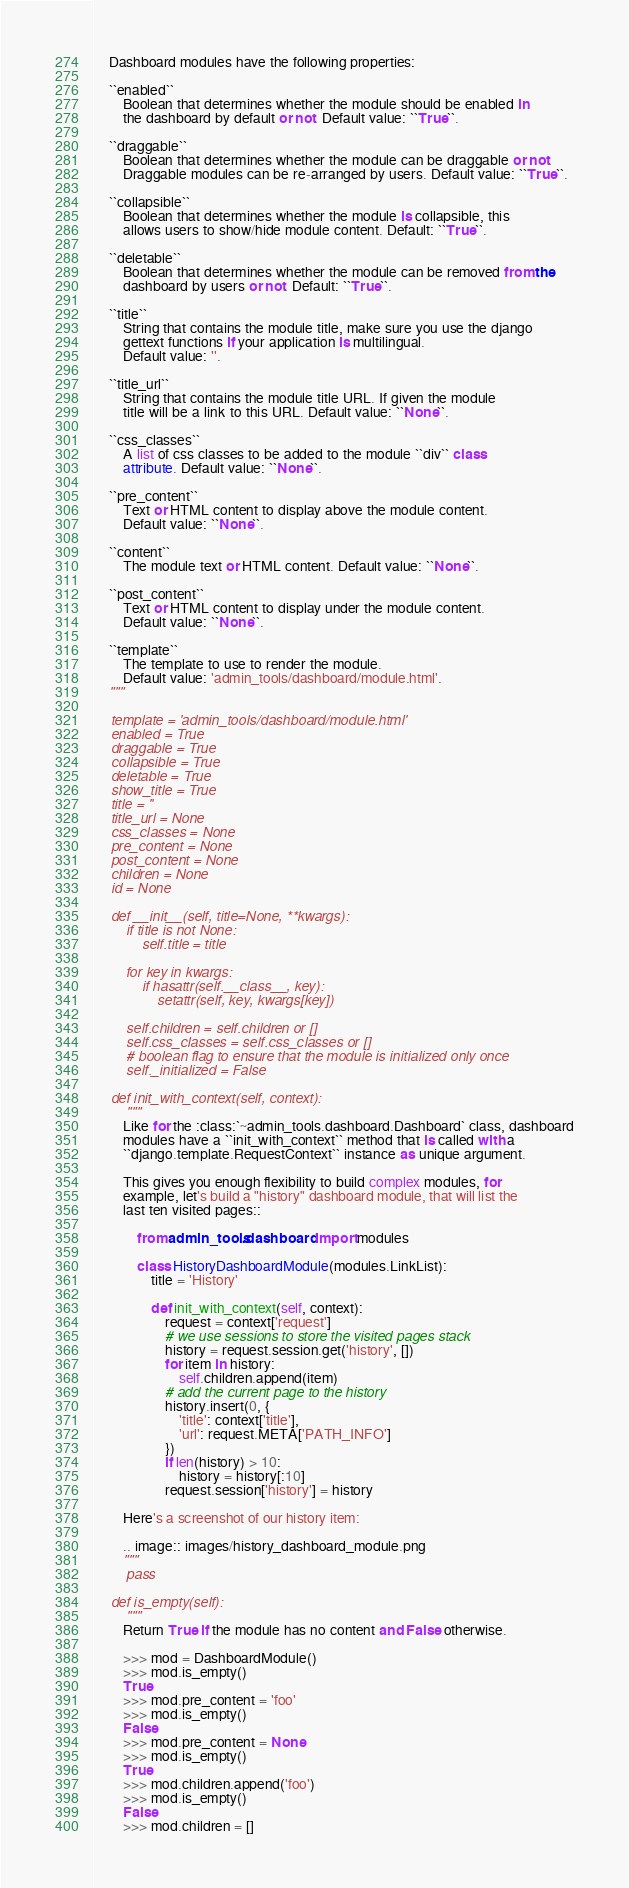Convert code to text. <code><loc_0><loc_0><loc_500><loc_500><_Python_>    Dashboard modules have the following properties:

    ``enabled``
        Boolean that determines whether the module should be enabled in
        the dashboard by default or not. Default value: ``True``.

    ``draggable``
        Boolean that determines whether the module can be draggable or not.
        Draggable modules can be re-arranged by users. Default value: ``True``.

    ``collapsible``
        Boolean that determines whether the module is collapsible, this
        allows users to show/hide module content. Default: ``True``.

    ``deletable``
        Boolean that determines whether the module can be removed from the
        dashboard by users or not. Default: ``True``.

    ``title``
        String that contains the module title, make sure you use the django
        gettext functions if your application is multilingual.
        Default value: ''.

    ``title_url``
        String that contains the module title URL. If given the module
        title will be a link to this URL. Default value: ``None``.

    ``css_classes``
        A list of css classes to be added to the module ``div`` class
        attribute. Default value: ``None``.

    ``pre_content``
        Text or HTML content to display above the module content.
        Default value: ``None``.

    ``content``
        The module text or HTML content. Default value: ``None``.

    ``post_content``
        Text or HTML content to display under the module content.
        Default value: ``None``.

    ``template``
        The template to use to render the module.
        Default value: 'admin_tools/dashboard/module.html'.
    """

    template = 'admin_tools/dashboard/module.html'
    enabled = True
    draggable = True
    collapsible = True
    deletable = True
    show_title = True
    title = ''
    title_url = None
    css_classes = None
    pre_content = None
    post_content = None
    children = None
    id = None

    def __init__(self, title=None, **kwargs):
        if title is not None:
            self.title = title

        for key in kwargs:
            if hasattr(self.__class__, key):
                setattr(self, key, kwargs[key])

        self.children = self.children or []
        self.css_classes = self.css_classes or []
        # boolean flag to ensure that the module is initialized only once
        self._initialized = False

    def init_with_context(self, context):
        """
        Like for the :class:`~admin_tools.dashboard.Dashboard` class, dashboard
        modules have a ``init_with_context`` method that is called with a
        ``django.template.RequestContext`` instance as unique argument.

        This gives you enough flexibility to build complex modules, for
        example, let's build a "history" dashboard module, that will list the
        last ten visited pages::

            from admin_tools.dashboard import modules

            class HistoryDashboardModule(modules.LinkList):
                title = 'History'

                def init_with_context(self, context):
                    request = context['request']
                    # we use sessions to store the visited pages stack
                    history = request.session.get('history', [])
                    for item in history:
                        self.children.append(item)
                    # add the current page to the history
                    history.insert(0, {
                        'title': context['title'],
                        'url': request.META['PATH_INFO']
                    })
                    if len(history) > 10:
                        history = history[:10]
                    request.session['history'] = history

        Here's a screenshot of our history item:

        .. image:: images/history_dashboard_module.png
        """
        pass

    def is_empty(self):
        """
        Return True if the module has no content and False otherwise.

        >>> mod = DashboardModule()
        >>> mod.is_empty()
        True
        >>> mod.pre_content = 'foo'
        >>> mod.is_empty()
        False
        >>> mod.pre_content = None
        >>> mod.is_empty()
        True
        >>> mod.children.append('foo')
        >>> mod.is_empty()
        False
        >>> mod.children = []</code> 